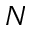Convert formula to latex. <formula><loc_0><loc_0><loc_500><loc_500>N</formula> 